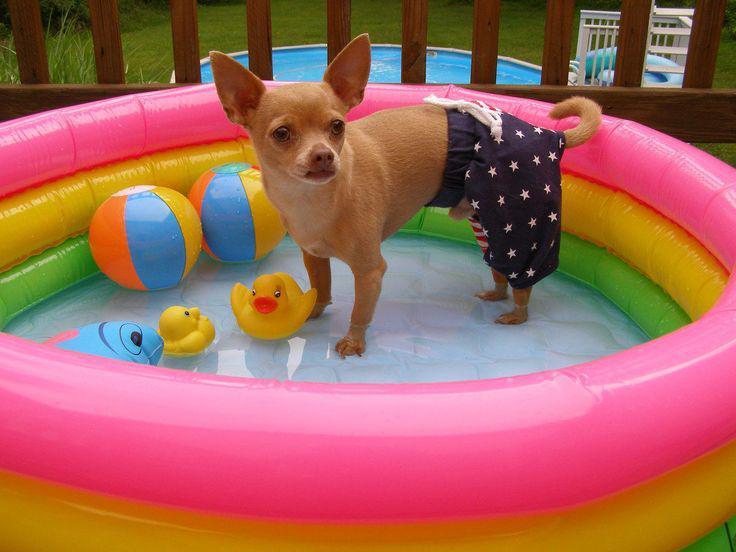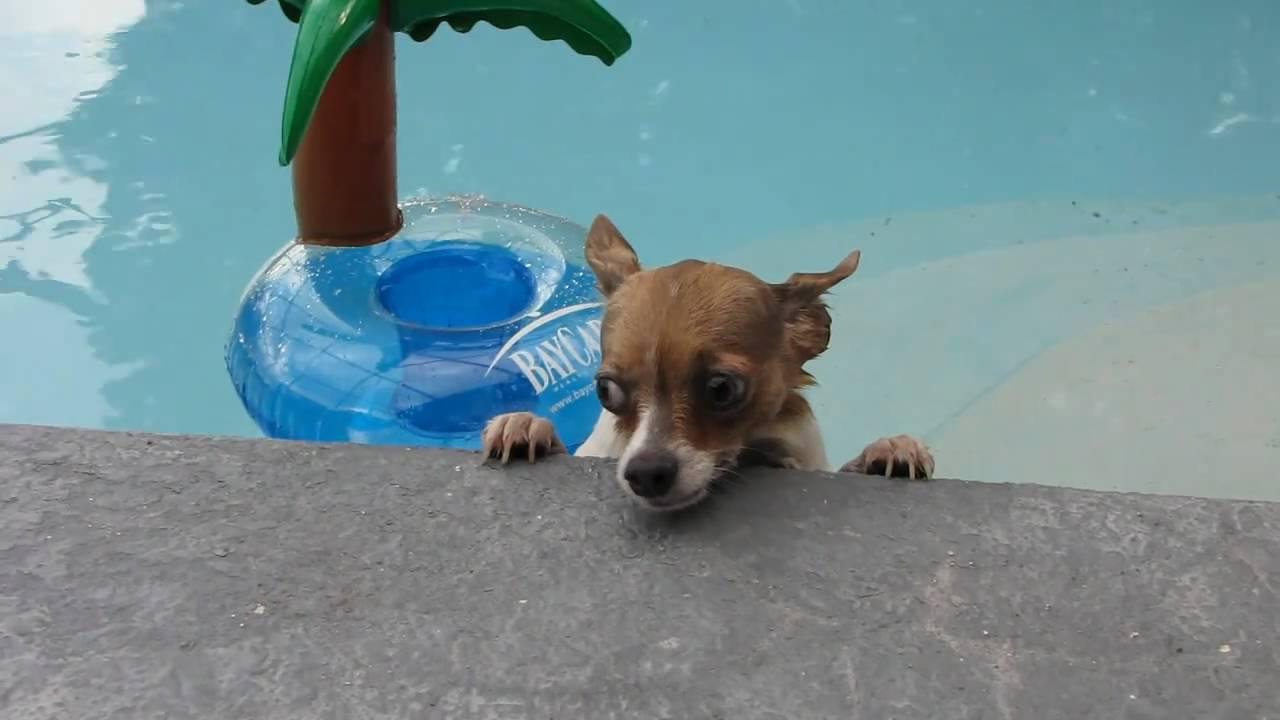The first image is the image on the left, the second image is the image on the right. Evaluate the accuracy of this statement regarding the images: "In one image, a small dog is standing in a kids' plastic pool, while the second image shows a similar dog in a large inground swimming pool, either in or near a floatation device.". Is it true? Answer yes or no. Yes. The first image is the image on the left, the second image is the image on the right. Evaluate the accuracy of this statement regarding the images: "A single dog is standing up inside a kiddie pool, in one image.". Is it true? Answer yes or no. Yes. 